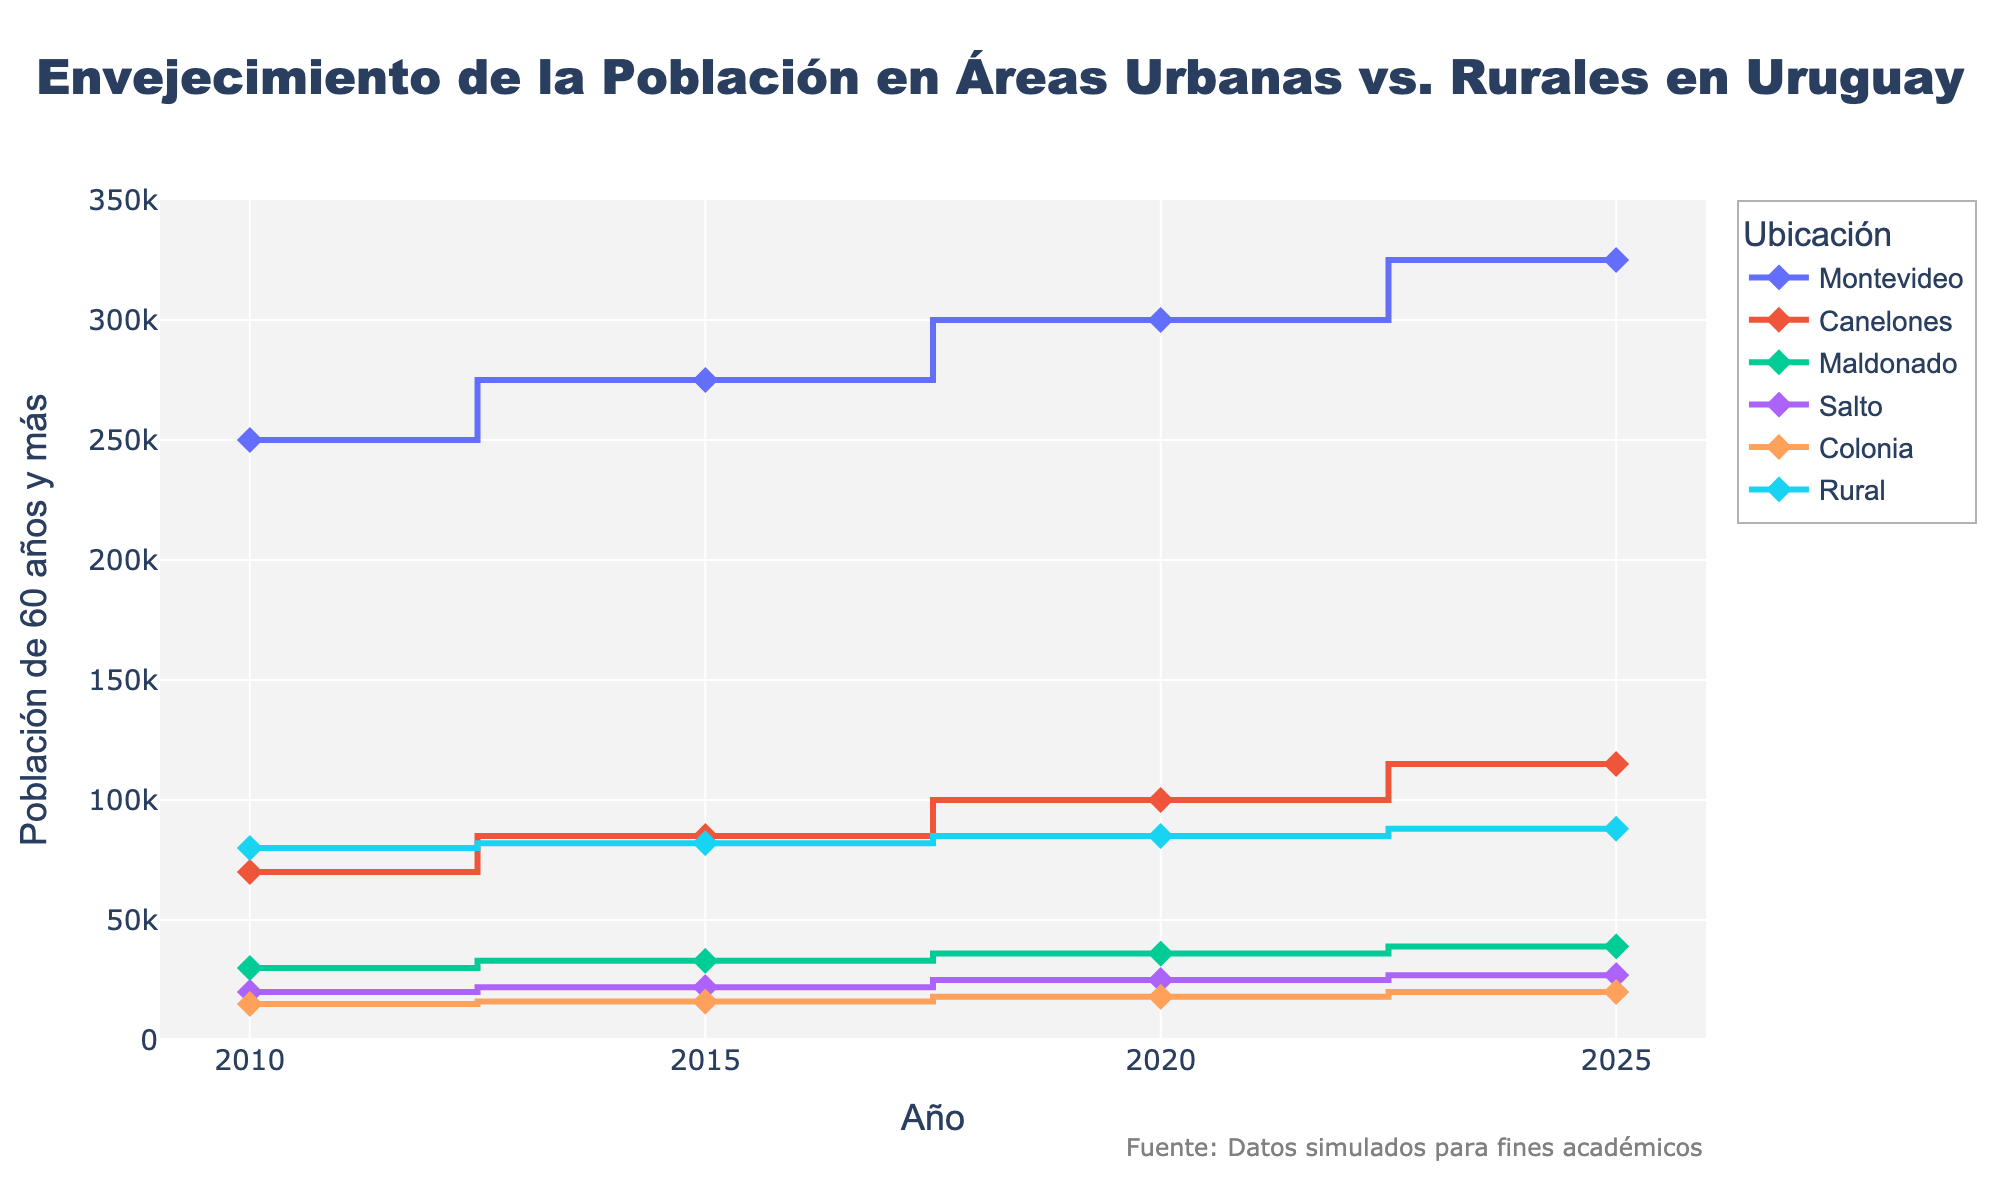What's the title of the figure? The title is located at the top of the figure, usually in a larger font size. In this case, the title is "Envejecimiento de la Población en Áreas Urbanas vs. Rurales en Uruguay."
Answer: Envejecimiento de la Población en Áreas Urbanas vs. Rurales en Uruguay Which location had the largest elderly population in 2020? To find this, look at the 2020 data points and compare the values. Montevideo has the largest elderly population with 300,000.
Answer: Montevideo What's the total elderly population in 2015 across all locations? Sum the 2015 population values for each location: 275,000 (Montevideo) + 85,000 (Canelones) + 33,000 (Maldonado) + 22,000 (Salto) + 16,000 (Colonia) + 82,000 (Rural) = 513,000.
Answer: 513,000 How did the elderly population in rural areas change from 2010 to 2025? Look at the data points for Rural in 2010 and 2025 and calculate the difference: 88,000 (2025) - 80,000 (2010) = 8,000.
Answer: Increased by 8,000 Which location had the most significant increase in elderly population from 2010 to 2025? Compare the differences in populations for all locations between 2010 and 2025. Montevideo had the largest increase: 325,000 - 250,000 = 75,000.
Answer: Montevideo Is the elderly population growth rate consistent across all locations between 2010 and 2025? Examine the stair-like lines representing each location. The lines do not match in slope and become more gradual or steeper at different points, indicating inconsistent growth rates among locations.
Answer: No, it varies by location What was the elderly population in Canelones in 2010 compared to 2025? Canelones in 2010 is 70,000, and in 2025 it is 115,000. The difference is 115,000 - 70,000 = 45,000.
Answer: Increased by 45,000 Which two locations have the closest elderly populations in 2020? Compare 2020 data points and find the closest pair. Maldonado (36,000) and Colonia (18,000) are closest in value.
Answer: Maldonado and Colonia What's the average elderly population in Montevideo over the given years? Sum Montevideo's populations for all years and divide by the number of years: (250,000 + 275,000 + 300,000 + 325,000) / 4 = 1,150,000 / 4 = 287,500.
Answer: 287,500 